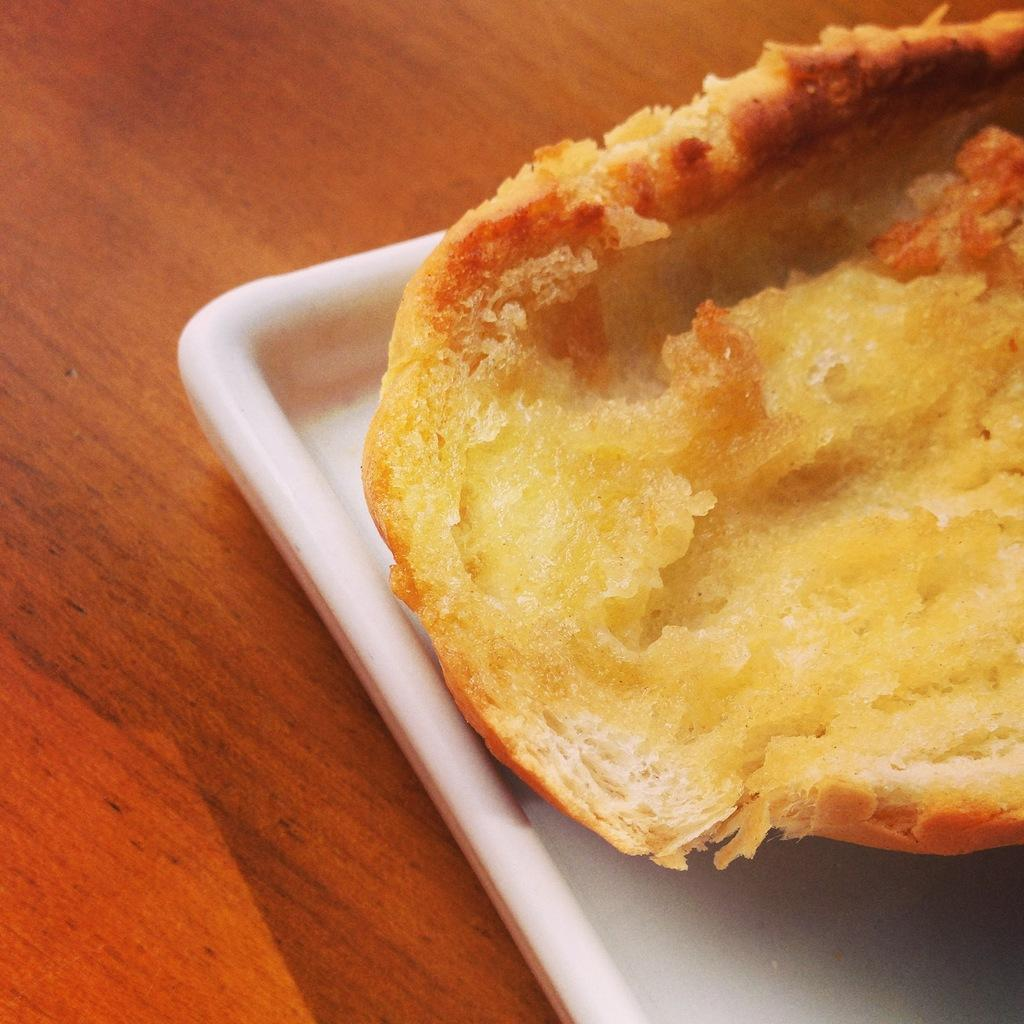What is on the plate that is visible in the image? There is food on a plate in the image. Where is the plate located in the image? The plate is on a table in the image. What type of government is depicted in the image? There is no government depicted in the image; it features a plate of food on a table. How does the camera capture the image? There is no camera present in the image; it is a still photograph or digital image. 